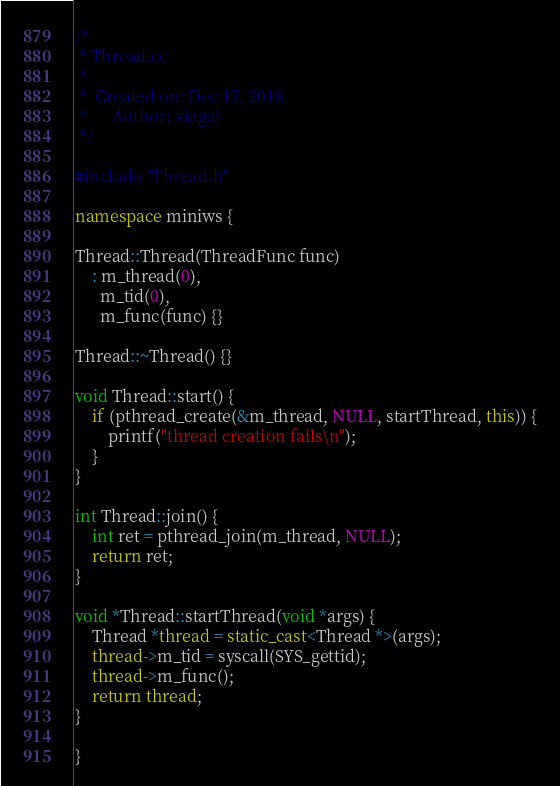<code> <loc_0><loc_0><loc_500><loc_500><_C++_>/*
 * Thread.cc
 *
 *  Created on: Dec 17, 2018
 *      Author: xiagai
 */

#include "Thread.h"

namespace miniws {

Thread::Thread(ThreadFunc func)
	: m_thread(0),
	  m_tid(0),
	  m_func(func) {}

Thread::~Thread() {}

void Thread::start() {
	if (pthread_create(&m_thread, NULL, startThread, this)) {
		printf("thread creation fails\n");
	}
}

int Thread::join() {
	int ret = pthread_join(m_thread, NULL);
	return ret;
}

void *Thread::startThread(void *args) {
	Thread *thread = static_cast<Thread *>(args);
	thread->m_tid = syscall(SYS_gettid);
	thread->m_func();
	return thread;
}

}


</code> 